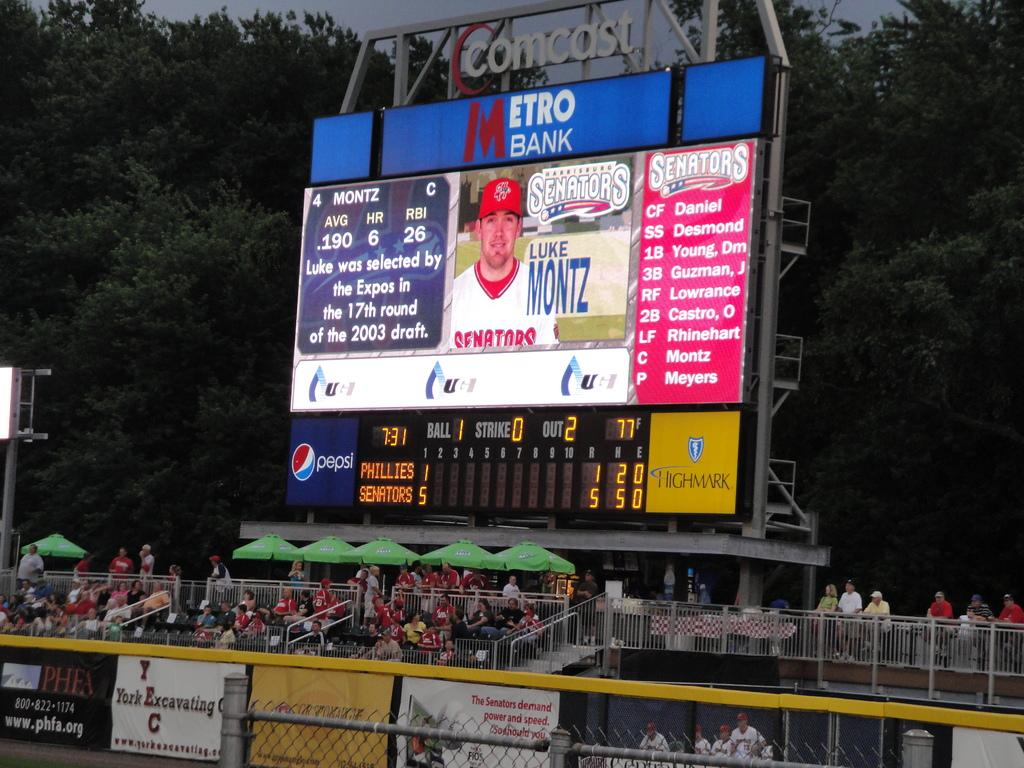<image>
Render a clear and concise summary of the photo. Big sign of an athletic on a metro bank banner with two teams playing baseball 